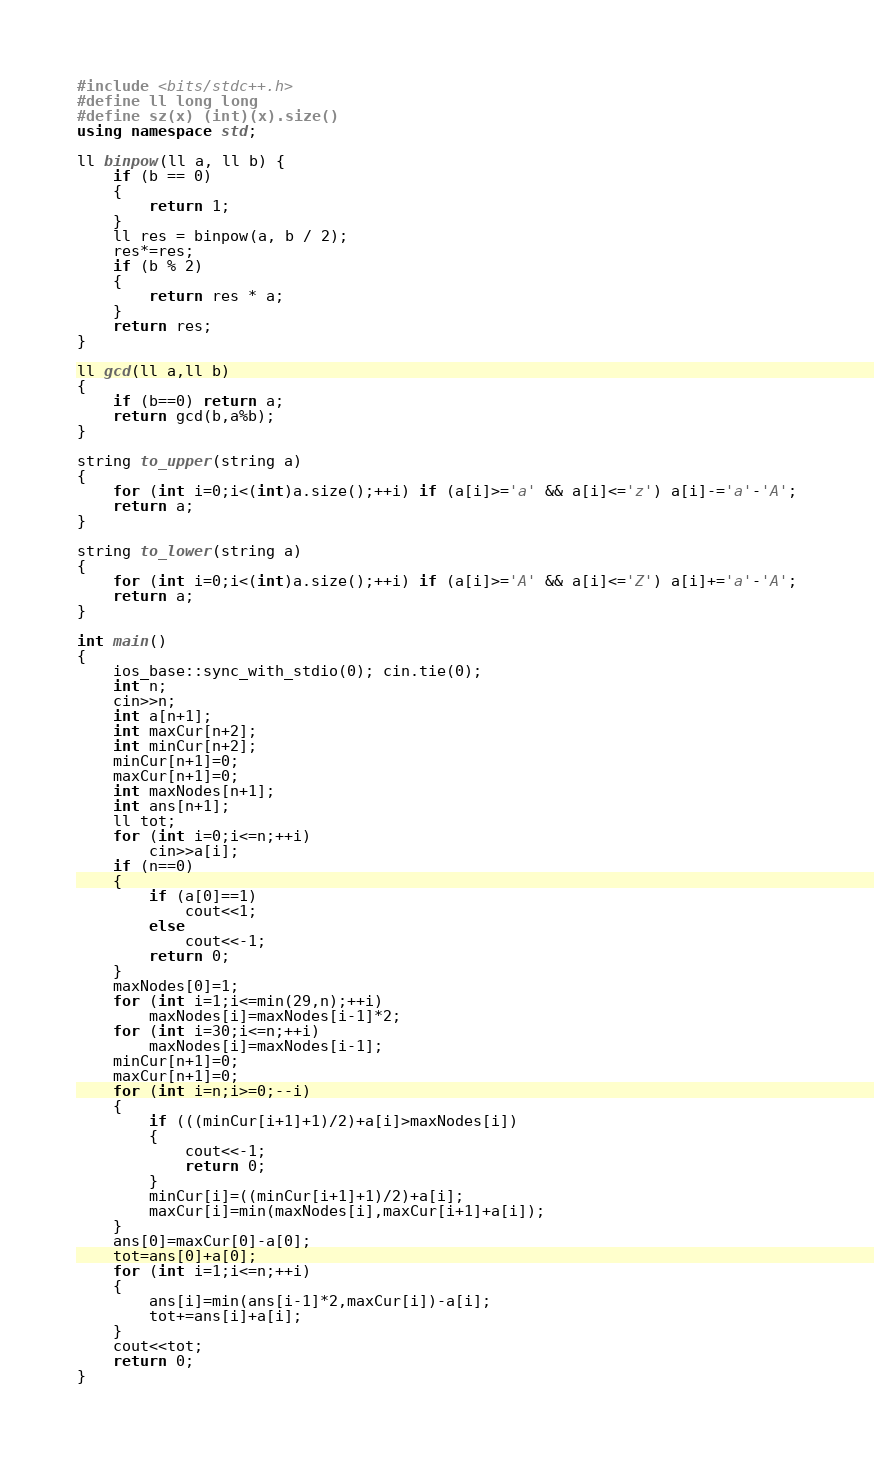Convert code to text. <code><loc_0><loc_0><loc_500><loc_500><_C++_>#include <bits/stdc++.h>
#define ll long long
#define sz(x) (int)(x).size()
using namespace std;

ll binpow(ll a, ll b) {
    if (b == 0)
    {
        return 1;
    }
    ll res = binpow(a, b / 2);
    res*=res;
    if (b % 2)
    {
        return res * a;
    }
    return res;
}

ll gcd(ll a,ll b)
{
    if (b==0) return a;
    return gcd(b,a%b);
}

string to_upper(string a)
{
    for (int i=0;i<(int)a.size();++i) if (a[i]>='a' && a[i]<='z') a[i]-='a'-'A';
    return a;
}
 
string to_lower(string a)
{
    for (int i=0;i<(int)a.size();++i) if (a[i]>='A' && a[i]<='Z') a[i]+='a'-'A';
    return a;
}

int main()
{
    ios_base::sync_with_stdio(0); cin.tie(0);
    int n;
    cin>>n;
    int a[n+1];
    int maxCur[n+2];
    int minCur[n+2];
    minCur[n+1]=0;
    maxCur[n+1]=0;
    int maxNodes[n+1];
    int ans[n+1];
    ll tot;
    for (int i=0;i<=n;++i)
        cin>>a[i];
    if (n==0)
    {
        if (a[0]==1)
            cout<<1;
        else
            cout<<-1;
        return 0;
    }
    maxNodes[0]=1;
    for (int i=1;i<=min(29,n);++i)
        maxNodes[i]=maxNodes[i-1]*2;
    for (int i=30;i<=n;++i)
        maxNodes[i]=maxNodes[i-1];
    minCur[n+1]=0;
    maxCur[n+1]=0;
    for (int i=n;i>=0;--i)
    {
        if (((minCur[i+1]+1)/2)+a[i]>maxNodes[i])
        {
            cout<<-1;
            return 0;
        }
        minCur[i]=((minCur[i+1]+1)/2)+a[i];
        maxCur[i]=min(maxNodes[i],maxCur[i+1]+a[i]);
    }
    ans[0]=maxCur[0]-a[0];
    tot=ans[0]+a[0];
    for (int i=1;i<=n;++i)
    {
        ans[i]=min(ans[i-1]*2,maxCur[i])-a[i];
        tot+=ans[i]+a[i];
    }
    cout<<tot;
    return 0;
}</code> 